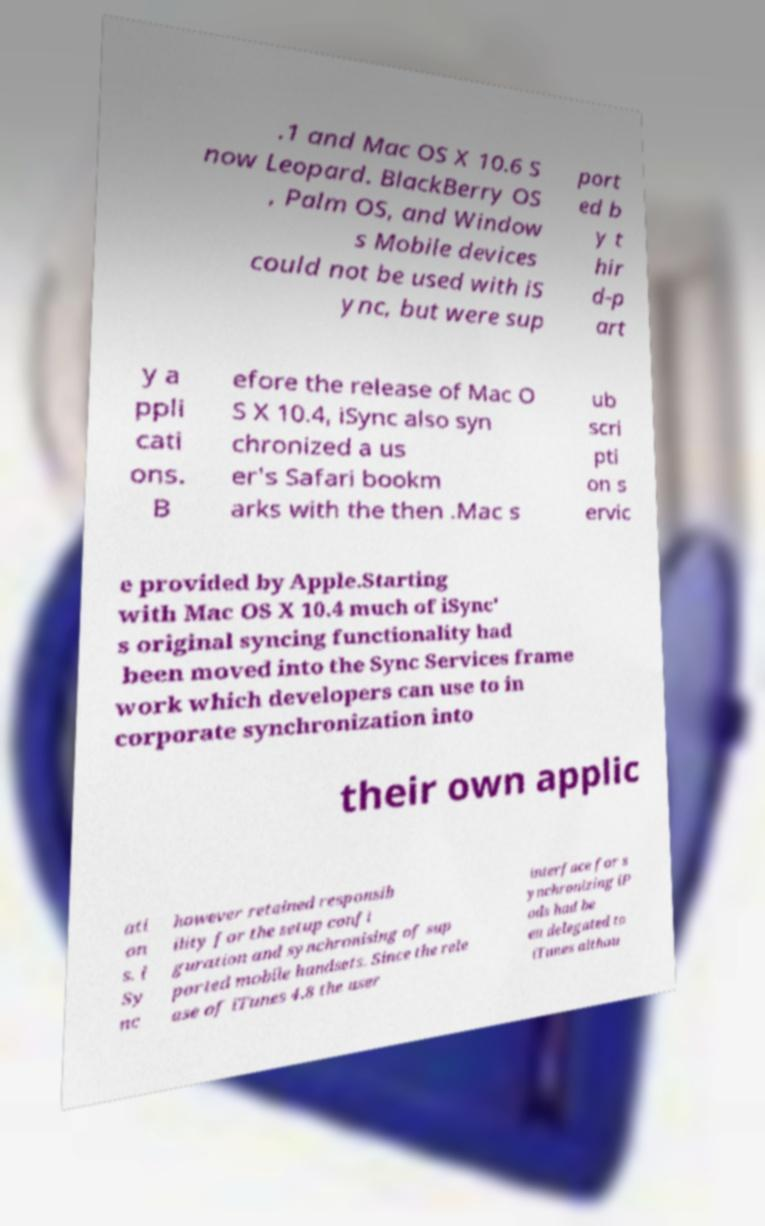Could you extract and type out the text from this image? .1 and Mac OS X 10.6 S now Leopard. BlackBerry OS , Palm OS, and Window s Mobile devices could not be used with iS ync, but were sup port ed b y t hir d-p art y a ppli cati ons. B efore the release of Mac O S X 10.4, iSync also syn chronized a us er's Safari bookm arks with the then .Mac s ub scri pti on s ervic e provided by Apple.Starting with Mac OS X 10.4 much of iSync' s original syncing functionality had been moved into the Sync Services frame work which developers can use to in corporate synchronization into their own applic ati on s. i Sy nc however retained responsib ility for the setup confi guration and synchronising of sup ported mobile handsets. Since the rele ase of iTunes 4.8 the user interface for s ynchronizing iP ods had be en delegated to iTunes althou 